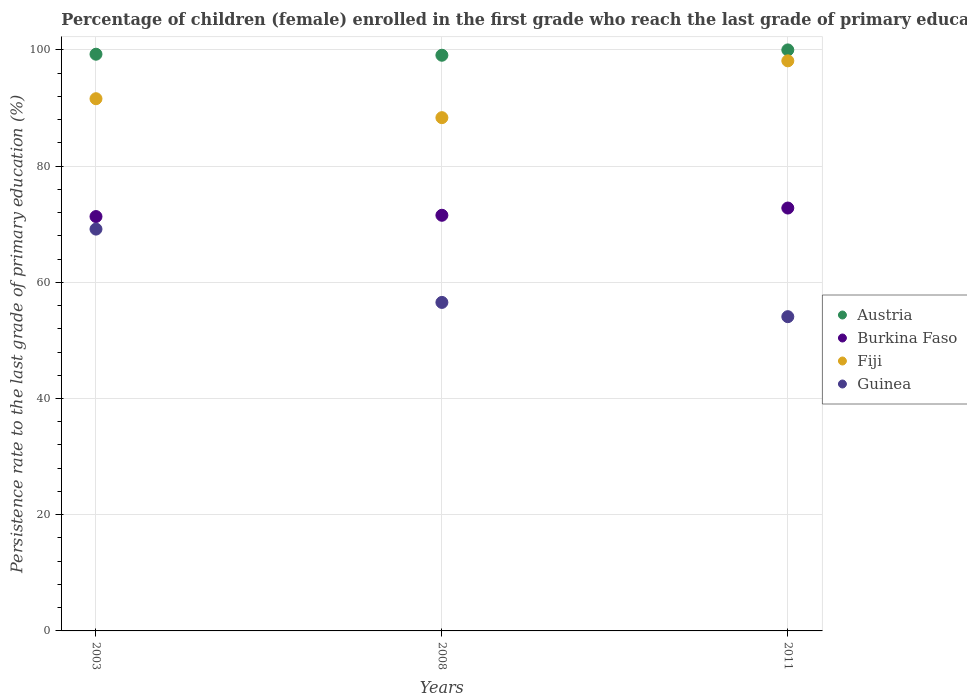Is the number of dotlines equal to the number of legend labels?
Offer a terse response. Yes. What is the persistence rate of children in Fiji in 2008?
Give a very brief answer. 88.34. Across all years, what is the maximum persistence rate of children in Fiji?
Give a very brief answer. 98.12. Across all years, what is the minimum persistence rate of children in Guinea?
Keep it short and to the point. 54.09. What is the total persistence rate of children in Austria in the graph?
Offer a very short reply. 298.34. What is the difference between the persistence rate of children in Austria in 2008 and that in 2011?
Offer a very short reply. -0.92. What is the difference between the persistence rate of children in Austria in 2011 and the persistence rate of children in Guinea in 2003?
Keep it short and to the point. 30.84. What is the average persistence rate of children in Burkina Faso per year?
Your answer should be compact. 71.88. In the year 2008, what is the difference between the persistence rate of children in Fiji and persistence rate of children in Burkina Faso?
Provide a succinct answer. 16.8. What is the ratio of the persistence rate of children in Burkina Faso in 2003 to that in 2011?
Your response must be concise. 0.98. Is the persistence rate of children in Austria in 2003 less than that in 2011?
Your answer should be compact. Yes. What is the difference between the highest and the second highest persistence rate of children in Burkina Faso?
Give a very brief answer. 1.25. What is the difference between the highest and the lowest persistence rate of children in Fiji?
Provide a short and direct response. 9.78. Is the sum of the persistence rate of children in Guinea in 2003 and 2008 greater than the maximum persistence rate of children in Fiji across all years?
Keep it short and to the point. Yes. Is the persistence rate of children in Fiji strictly less than the persistence rate of children in Burkina Faso over the years?
Your response must be concise. No. How many dotlines are there?
Keep it short and to the point. 4. What is the difference between two consecutive major ticks on the Y-axis?
Make the answer very short. 20. Does the graph contain any zero values?
Your answer should be very brief. No. Does the graph contain grids?
Your response must be concise. Yes. Where does the legend appear in the graph?
Keep it short and to the point. Center right. How are the legend labels stacked?
Your answer should be very brief. Vertical. What is the title of the graph?
Your answer should be compact. Percentage of children (female) enrolled in the first grade who reach the last grade of primary education. Does "Virgin Islands" appear as one of the legend labels in the graph?
Provide a short and direct response. No. What is the label or title of the X-axis?
Make the answer very short. Years. What is the label or title of the Y-axis?
Give a very brief answer. Persistence rate to the last grade of primary education (%). What is the Persistence rate to the last grade of primary education (%) in Austria in 2003?
Provide a succinct answer. 99.26. What is the Persistence rate to the last grade of primary education (%) in Burkina Faso in 2003?
Give a very brief answer. 71.32. What is the Persistence rate to the last grade of primary education (%) of Fiji in 2003?
Offer a very short reply. 91.6. What is the Persistence rate to the last grade of primary education (%) in Guinea in 2003?
Offer a very short reply. 69.16. What is the Persistence rate to the last grade of primary education (%) in Austria in 2008?
Provide a short and direct response. 99.08. What is the Persistence rate to the last grade of primary education (%) in Burkina Faso in 2008?
Ensure brevity in your answer.  71.54. What is the Persistence rate to the last grade of primary education (%) in Fiji in 2008?
Give a very brief answer. 88.34. What is the Persistence rate to the last grade of primary education (%) in Guinea in 2008?
Offer a terse response. 56.54. What is the Persistence rate to the last grade of primary education (%) in Austria in 2011?
Provide a short and direct response. 100. What is the Persistence rate to the last grade of primary education (%) in Burkina Faso in 2011?
Offer a very short reply. 72.79. What is the Persistence rate to the last grade of primary education (%) in Fiji in 2011?
Keep it short and to the point. 98.12. What is the Persistence rate to the last grade of primary education (%) of Guinea in 2011?
Your response must be concise. 54.09. Across all years, what is the maximum Persistence rate to the last grade of primary education (%) of Burkina Faso?
Offer a terse response. 72.79. Across all years, what is the maximum Persistence rate to the last grade of primary education (%) of Fiji?
Your answer should be very brief. 98.12. Across all years, what is the maximum Persistence rate to the last grade of primary education (%) of Guinea?
Provide a short and direct response. 69.16. Across all years, what is the minimum Persistence rate to the last grade of primary education (%) in Austria?
Your response must be concise. 99.08. Across all years, what is the minimum Persistence rate to the last grade of primary education (%) of Burkina Faso?
Give a very brief answer. 71.32. Across all years, what is the minimum Persistence rate to the last grade of primary education (%) of Fiji?
Offer a very short reply. 88.34. Across all years, what is the minimum Persistence rate to the last grade of primary education (%) in Guinea?
Provide a short and direct response. 54.09. What is the total Persistence rate to the last grade of primary education (%) in Austria in the graph?
Provide a succinct answer. 298.34. What is the total Persistence rate to the last grade of primary education (%) in Burkina Faso in the graph?
Your response must be concise. 215.64. What is the total Persistence rate to the last grade of primary education (%) of Fiji in the graph?
Your response must be concise. 278.06. What is the total Persistence rate to the last grade of primary education (%) in Guinea in the graph?
Offer a terse response. 179.79. What is the difference between the Persistence rate to the last grade of primary education (%) of Austria in 2003 and that in 2008?
Keep it short and to the point. 0.18. What is the difference between the Persistence rate to the last grade of primary education (%) of Burkina Faso in 2003 and that in 2008?
Provide a short and direct response. -0.22. What is the difference between the Persistence rate to the last grade of primary education (%) of Fiji in 2003 and that in 2008?
Your answer should be very brief. 3.26. What is the difference between the Persistence rate to the last grade of primary education (%) in Guinea in 2003 and that in 2008?
Your response must be concise. 12.62. What is the difference between the Persistence rate to the last grade of primary education (%) of Austria in 2003 and that in 2011?
Your answer should be compact. -0.74. What is the difference between the Persistence rate to the last grade of primary education (%) in Burkina Faso in 2003 and that in 2011?
Provide a succinct answer. -1.47. What is the difference between the Persistence rate to the last grade of primary education (%) of Fiji in 2003 and that in 2011?
Offer a terse response. -6.52. What is the difference between the Persistence rate to the last grade of primary education (%) of Guinea in 2003 and that in 2011?
Provide a short and direct response. 15.07. What is the difference between the Persistence rate to the last grade of primary education (%) in Austria in 2008 and that in 2011?
Offer a very short reply. -0.92. What is the difference between the Persistence rate to the last grade of primary education (%) of Burkina Faso in 2008 and that in 2011?
Offer a terse response. -1.25. What is the difference between the Persistence rate to the last grade of primary education (%) of Fiji in 2008 and that in 2011?
Give a very brief answer. -9.78. What is the difference between the Persistence rate to the last grade of primary education (%) in Guinea in 2008 and that in 2011?
Make the answer very short. 2.45. What is the difference between the Persistence rate to the last grade of primary education (%) in Austria in 2003 and the Persistence rate to the last grade of primary education (%) in Burkina Faso in 2008?
Your answer should be compact. 27.72. What is the difference between the Persistence rate to the last grade of primary education (%) of Austria in 2003 and the Persistence rate to the last grade of primary education (%) of Fiji in 2008?
Offer a terse response. 10.92. What is the difference between the Persistence rate to the last grade of primary education (%) in Austria in 2003 and the Persistence rate to the last grade of primary education (%) in Guinea in 2008?
Your response must be concise. 42.72. What is the difference between the Persistence rate to the last grade of primary education (%) of Burkina Faso in 2003 and the Persistence rate to the last grade of primary education (%) of Fiji in 2008?
Your response must be concise. -17.02. What is the difference between the Persistence rate to the last grade of primary education (%) of Burkina Faso in 2003 and the Persistence rate to the last grade of primary education (%) of Guinea in 2008?
Your answer should be very brief. 14.78. What is the difference between the Persistence rate to the last grade of primary education (%) in Fiji in 2003 and the Persistence rate to the last grade of primary education (%) in Guinea in 2008?
Give a very brief answer. 35.06. What is the difference between the Persistence rate to the last grade of primary education (%) of Austria in 2003 and the Persistence rate to the last grade of primary education (%) of Burkina Faso in 2011?
Offer a terse response. 26.47. What is the difference between the Persistence rate to the last grade of primary education (%) of Austria in 2003 and the Persistence rate to the last grade of primary education (%) of Fiji in 2011?
Offer a very short reply. 1.14. What is the difference between the Persistence rate to the last grade of primary education (%) in Austria in 2003 and the Persistence rate to the last grade of primary education (%) in Guinea in 2011?
Your response must be concise. 45.17. What is the difference between the Persistence rate to the last grade of primary education (%) in Burkina Faso in 2003 and the Persistence rate to the last grade of primary education (%) in Fiji in 2011?
Your answer should be very brief. -26.8. What is the difference between the Persistence rate to the last grade of primary education (%) in Burkina Faso in 2003 and the Persistence rate to the last grade of primary education (%) in Guinea in 2011?
Provide a short and direct response. 17.23. What is the difference between the Persistence rate to the last grade of primary education (%) of Fiji in 2003 and the Persistence rate to the last grade of primary education (%) of Guinea in 2011?
Your answer should be very brief. 37.51. What is the difference between the Persistence rate to the last grade of primary education (%) in Austria in 2008 and the Persistence rate to the last grade of primary education (%) in Burkina Faso in 2011?
Your answer should be very brief. 26.3. What is the difference between the Persistence rate to the last grade of primary education (%) of Austria in 2008 and the Persistence rate to the last grade of primary education (%) of Fiji in 2011?
Make the answer very short. 0.96. What is the difference between the Persistence rate to the last grade of primary education (%) in Austria in 2008 and the Persistence rate to the last grade of primary education (%) in Guinea in 2011?
Keep it short and to the point. 45. What is the difference between the Persistence rate to the last grade of primary education (%) in Burkina Faso in 2008 and the Persistence rate to the last grade of primary education (%) in Fiji in 2011?
Make the answer very short. -26.58. What is the difference between the Persistence rate to the last grade of primary education (%) in Burkina Faso in 2008 and the Persistence rate to the last grade of primary education (%) in Guinea in 2011?
Offer a very short reply. 17.45. What is the difference between the Persistence rate to the last grade of primary education (%) of Fiji in 2008 and the Persistence rate to the last grade of primary education (%) of Guinea in 2011?
Provide a short and direct response. 34.25. What is the average Persistence rate to the last grade of primary education (%) of Austria per year?
Make the answer very short. 99.45. What is the average Persistence rate to the last grade of primary education (%) in Burkina Faso per year?
Provide a succinct answer. 71.88. What is the average Persistence rate to the last grade of primary education (%) of Fiji per year?
Provide a succinct answer. 92.69. What is the average Persistence rate to the last grade of primary education (%) of Guinea per year?
Your answer should be compact. 59.93. In the year 2003, what is the difference between the Persistence rate to the last grade of primary education (%) of Austria and Persistence rate to the last grade of primary education (%) of Burkina Faso?
Offer a very short reply. 27.94. In the year 2003, what is the difference between the Persistence rate to the last grade of primary education (%) of Austria and Persistence rate to the last grade of primary education (%) of Fiji?
Provide a succinct answer. 7.66. In the year 2003, what is the difference between the Persistence rate to the last grade of primary education (%) in Austria and Persistence rate to the last grade of primary education (%) in Guinea?
Your answer should be compact. 30.1. In the year 2003, what is the difference between the Persistence rate to the last grade of primary education (%) in Burkina Faso and Persistence rate to the last grade of primary education (%) in Fiji?
Offer a terse response. -20.28. In the year 2003, what is the difference between the Persistence rate to the last grade of primary education (%) of Burkina Faso and Persistence rate to the last grade of primary education (%) of Guinea?
Keep it short and to the point. 2.16. In the year 2003, what is the difference between the Persistence rate to the last grade of primary education (%) in Fiji and Persistence rate to the last grade of primary education (%) in Guinea?
Offer a very short reply. 22.44. In the year 2008, what is the difference between the Persistence rate to the last grade of primary education (%) in Austria and Persistence rate to the last grade of primary education (%) in Burkina Faso?
Make the answer very short. 27.54. In the year 2008, what is the difference between the Persistence rate to the last grade of primary education (%) of Austria and Persistence rate to the last grade of primary education (%) of Fiji?
Offer a very short reply. 10.74. In the year 2008, what is the difference between the Persistence rate to the last grade of primary education (%) of Austria and Persistence rate to the last grade of primary education (%) of Guinea?
Keep it short and to the point. 42.54. In the year 2008, what is the difference between the Persistence rate to the last grade of primary education (%) of Burkina Faso and Persistence rate to the last grade of primary education (%) of Fiji?
Provide a succinct answer. -16.8. In the year 2008, what is the difference between the Persistence rate to the last grade of primary education (%) in Burkina Faso and Persistence rate to the last grade of primary education (%) in Guinea?
Offer a very short reply. 15. In the year 2008, what is the difference between the Persistence rate to the last grade of primary education (%) of Fiji and Persistence rate to the last grade of primary education (%) of Guinea?
Your answer should be compact. 31.8. In the year 2011, what is the difference between the Persistence rate to the last grade of primary education (%) in Austria and Persistence rate to the last grade of primary education (%) in Burkina Faso?
Make the answer very short. 27.21. In the year 2011, what is the difference between the Persistence rate to the last grade of primary education (%) in Austria and Persistence rate to the last grade of primary education (%) in Fiji?
Ensure brevity in your answer.  1.88. In the year 2011, what is the difference between the Persistence rate to the last grade of primary education (%) of Austria and Persistence rate to the last grade of primary education (%) of Guinea?
Your answer should be very brief. 45.91. In the year 2011, what is the difference between the Persistence rate to the last grade of primary education (%) of Burkina Faso and Persistence rate to the last grade of primary education (%) of Fiji?
Your answer should be very brief. -25.34. In the year 2011, what is the difference between the Persistence rate to the last grade of primary education (%) of Burkina Faso and Persistence rate to the last grade of primary education (%) of Guinea?
Offer a terse response. 18.7. In the year 2011, what is the difference between the Persistence rate to the last grade of primary education (%) in Fiji and Persistence rate to the last grade of primary education (%) in Guinea?
Provide a short and direct response. 44.03. What is the ratio of the Persistence rate to the last grade of primary education (%) of Austria in 2003 to that in 2008?
Your answer should be compact. 1. What is the ratio of the Persistence rate to the last grade of primary education (%) in Fiji in 2003 to that in 2008?
Provide a short and direct response. 1.04. What is the ratio of the Persistence rate to the last grade of primary education (%) in Guinea in 2003 to that in 2008?
Your response must be concise. 1.22. What is the ratio of the Persistence rate to the last grade of primary education (%) of Austria in 2003 to that in 2011?
Ensure brevity in your answer.  0.99. What is the ratio of the Persistence rate to the last grade of primary education (%) in Burkina Faso in 2003 to that in 2011?
Give a very brief answer. 0.98. What is the ratio of the Persistence rate to the last grade of primary education (%) of Fiji in 2003 to that in 2011?
Provide a succinct answer. 0.93. What is the ratio of the Persistence rate to the last grade of primary education (%) of Guinea in 2003 to that in 2011?
Provide a succinct answer. 1.28. What is the ratio of the Persistence rate to the last grade of primary education (%) of Austria in 2008 to that in 2011?
Provide a short and direct response. 0.99. What is the ratio of the Persistence rate to the last grade of primary education (%) of Burkina Faso in 2008 to that in 2011?
Keep it short and to the point. 0.98. What is the ratio of the Persistence rate to the last grade of primary education (%) in Fiji in 2008 to that in 2011?
Provide a short and direct response. 0.9. What is the ratio of the Persistence rate to the last grade of primary education (%) in Guinea in 2008 to that in 2011?
Provide a succinct answer. 1.05. What is the difference between the highest and the second highest Persistence rate to the last grade of primary education (%) in Austria?
Your response must be concise. 0.74. What is the difference between the highest and the second highest Persistence rate to the last grade of primary education (%) in Burkina Faso?
Your response must be concise. 1.25. What is the difference between the highest and the second highest Persistence rate to the last grade of primary education (%) of Fiji?
Provide a short and direct response. 6.52. What is the difference between the highest and the second highest Persistence rate to the last grade of primary education (%) of Guinea?
Provide a succinct answer. 12.62. What is the difference between the highest and the lowest Persistence rate to the last grade of primary education (%) of Austria?
Keep it short and to the point. 0.92. What is the difference between the highest and the lowest Persistence rate to the last grade of primary education (%) of Burkina Faso?
Offer a very short reply. 1.47. What is the difference between the highest and the lowest Persistence rate to the last grade of primary education (%) of Fiji?
Give a very brief answer. 9.78. What is the difference between the highest and the lowest Persistence rate to the last grade of primary education (%) of Guinea?
Your response must be concise. 15.07. 